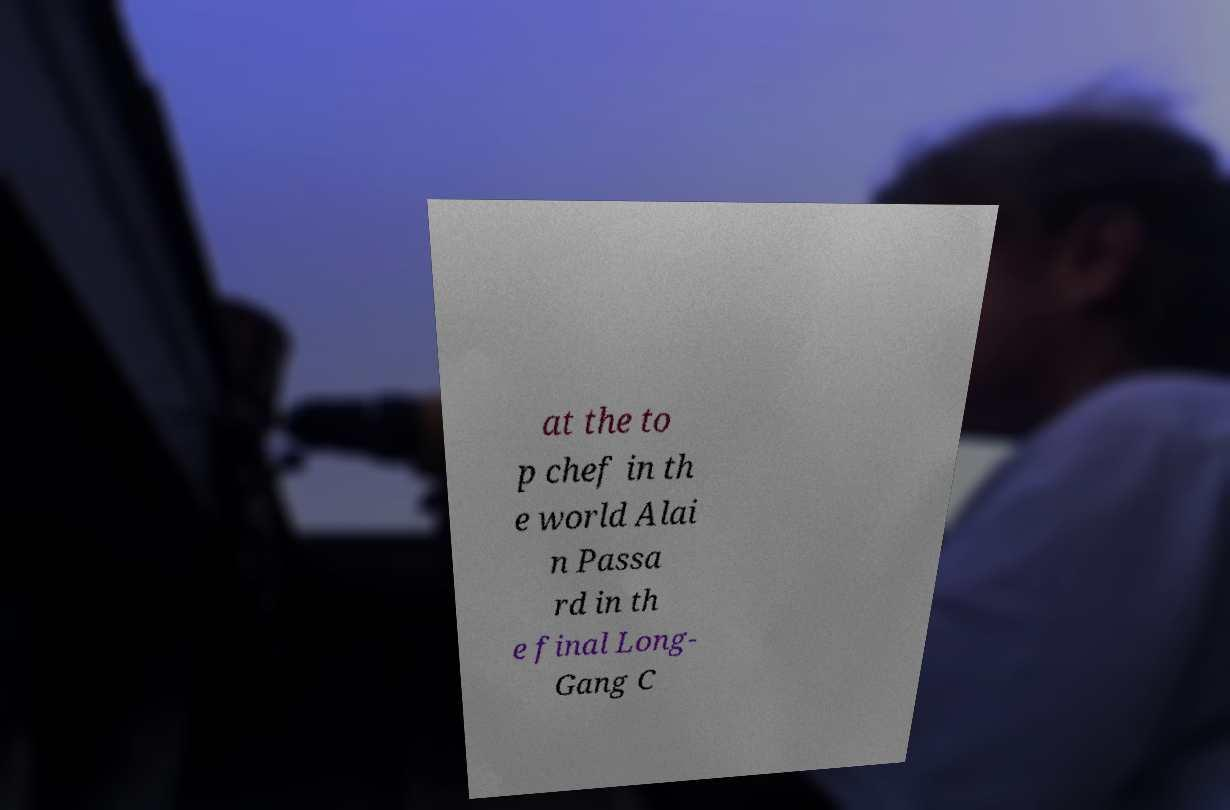Please identify and transcribe the text found in this image. at the to p chef in th e world Alai n Passa rd in th e final Long- Gang C 